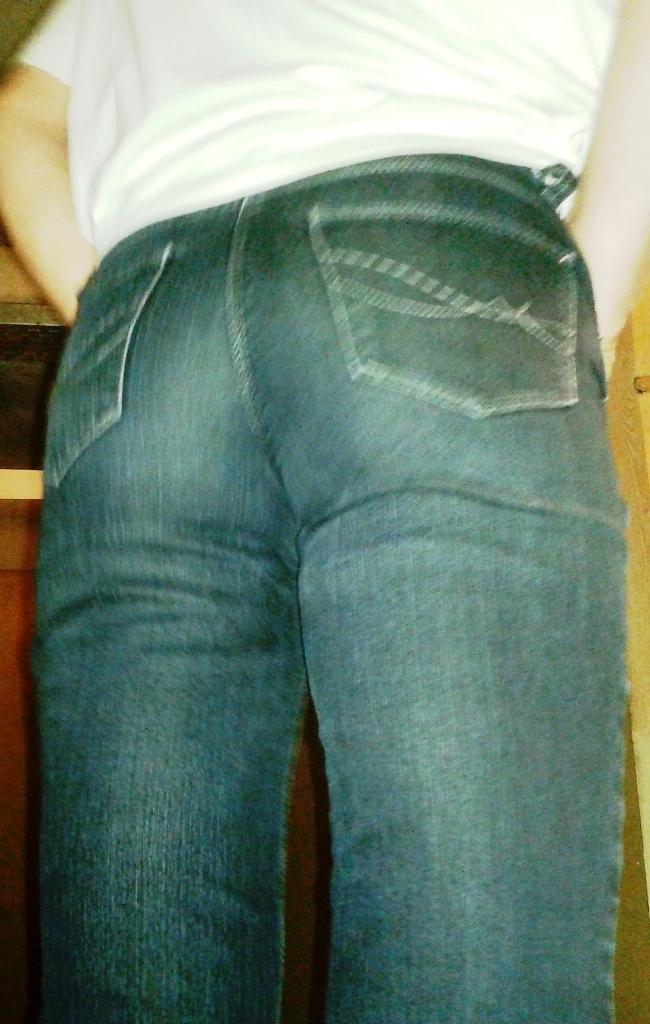Could you give a brief overview of what you see in this image? In the image we can see a person standing, wearing clothes. 